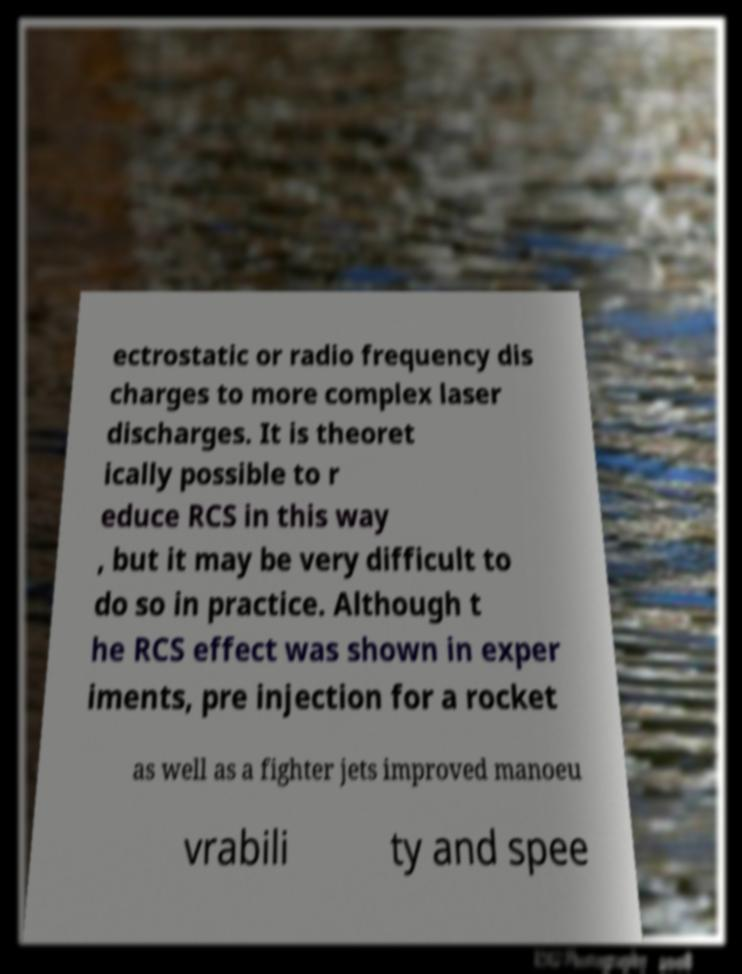I need the written content from this picture converted into text. Can you do that? ectrostatic or radio frequency dis charges to more complex laser discharges. It is theoret ically possible to r educe RCS in this way , but it may be very difficult to do so in practice. Although t he RCS effect was shown in exper iments, pre injection for a rocket as well as a fighter jets improved manoeu vrabili ty and spee 